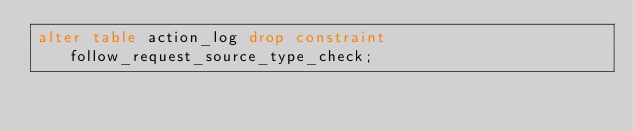<code> <loc_0><loc_0><loc_500><loc_500><_SQL_>alter table action_log drop constraint follow_request_source_type_check;</code> 